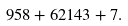Convert formula to latex. <formula><loc_0><loc_0><loc_500><loc_500>9 5 8 + 6 2 1 4 3 + 7 .</formula> 